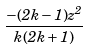<formula> <loc_0><loc_0><loc_500><loc_500>\frac { - ( 2 k - 1 ) z ^ { 2 } } { k ( 2 k + 1 ) }</formula> 